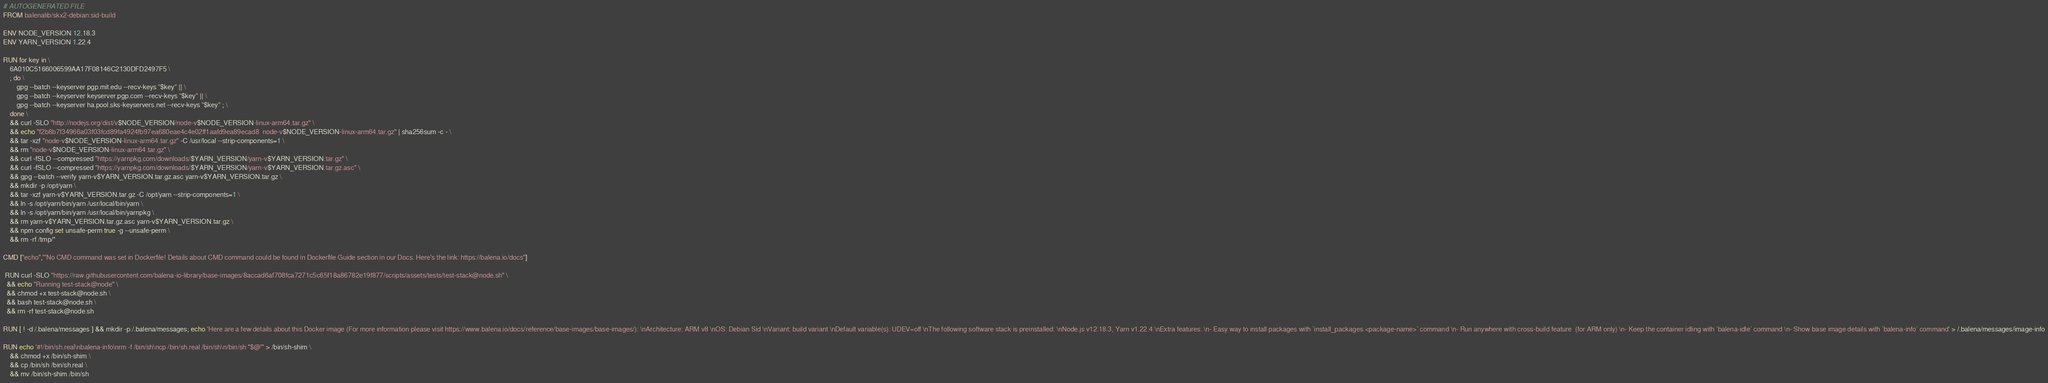<code> <loc_0><loc_0><loc_500><loc_500><_Dockerfile_># AUTOGENERATED FILE
FROM balenalib/skx2-debian:sid-build

ENV NODE_VERSION 12.18.3
ENV YARN_VERSION 1.22.4

RUN for key in \
	6A010C5166006599AA17F08146C2130DFD2497F5 \
	; do \
		gpg --batch --keyserver pgp.mit.edu --recv-keys "$key" || \
		gpg --batch --keyserver keyserver.pgp.com --recv-keys "$key" || \
		gpg --batch --keyserver ha.pool.sks-keyservers.net --recv-keys "$key" ; \
	done \
	&& curl -SLO "http://nodejs.org/dist/v$NODE_VERSION/node-v$NODE_VERSION-linux-arm64.tar.gz" \
	&& echo "f2b8b7f34966a03f03fcd89fa4924fb97ea680eae4c4e02ff1aafd9ea89ecad8  node-v$NODE_VERSION-linux-arm64.tar.gz" | sha256sum -c - \
	&& tar -xzf "node-v$NODE_VERSION-linux-arm64.tar.gz" -C /usr/local --strip-components=1 \
	&& rm "node-v$NODE_VERSION-linux-arm64.tar.gz" \
	&& curl -fSLO --compressed "https://yarnpkg.com/downloads/$YARN_VERSION/yarn-v$YARN_VERSION.tar.gz" \
	&& curl -fSLO --compressed "https://yarnpkg.com/downloads/$YARN_VERSION/yarn-v$YARN_VERSION.tar.gz.asc" \
	&& gpg --batch --verify yarn-v$YARN_VERSION.tar.gz.asc yarn-v$YARN_VERSION.tar.gz \
	&& mkdir -p /opt/yarn \
	&& tar -xzf yarn-v$YARN_VERSION.tar.gz -C /opt/yarn --strip-components=1 \
	&& ln -s /opt/yarn/bin/yarn /usr/local/bin/yarn \
	&& ln -s /opt/yarn/bin/yarn /usr/local/bin/yarnpkg \
	&& rm yarn-v$YARN_VERSION.tar.gz.asc yarn-v$YARN_VERSION.tar.gz \
	&& npm config set unsafe-perm true -g --unsafe-perm \
	&& rm -rf /tmp/*

CMD ["echo","'No CMD command was set in Dockerfile! Details about CMD command could be found in Dockerfile Guide section in our Docs. Here's the link: https://balena.io/docs"]

 RUN curl -SLO "https://raw.githubusercontent.com/balena-io-library/base-images/8accad6af708fca7271c5c65f18a86782e19f877/scripts/assets/tests/test-stack@node.sh" \
  && echo "Running test-stack@node" \
  && chmod +x test-stack@node.sh \
  && bash test-stack@node.sh \
  && rm -rf test-stack@node.sh 

RUN [ ! -d /.balena/messages ] && mkdir -p /.balena/messages; echo 'Here are a few details about this Docker image (For more information please visit https://www.balena.io/docs/reference/base-images/base-images/): \nArchitecture: ARM v8 \nOS: Debian Sid \nVariant: build variant \nDefault variable(s): UDEV=off \nThe following software stack is preinstalled: \nNode.js v12.18.3, Yarn v1.22.4 \nExtra features: \n- Easy way to install packages with `install_packages <package-name>` command \n- Run anywhere with cross-build feature  (for ARM only) \n- Keep the container idling with `balena-idle` command \n- Show base image details with `balena-info` command' > /.balena/messages/image-info

RUN echo '#!/bin/sh.real\nbalena-info\nrm -f /bin/sh\ncp /bin/sh.real /bin/sh\n/bin/sh "$@"' > /bin/sh-shim \
	&& chmod +x /bin/sh-shim \
	&& cp /bin/sh /bin/sh.real \
	&& mv /bin/sh-shim /bin/sh</code> 